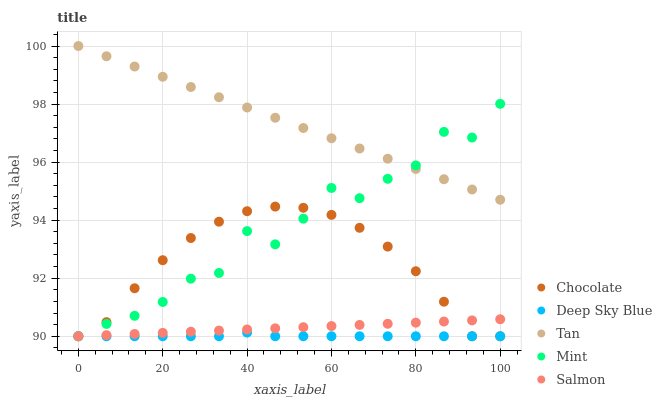Does Deep Sky Blue have the minimum area under the curve?
Answer yes or no. Yes. Does Tan have the maximum area under the curve?
Answer yes or no. Yes. Does Mint have the minimum area under the curve?
Answer yes or no. No. Does Mint have the maximum area under the curve?
Answer yes or no. No. Is Salmon the smoothest?
Answer yes or no. Yes. Is Mint the roughest?
Answer yes or no. Yes. Is Tan the smoothest?
Answer yes or no. No. Is Tan the roughest?
Answer yes or no. No. Does Salmon have the lowest value?
Answer yes or no. Yes. Does Tan have the lowest value?
Answer yes or no. No. Does Tan have the highest value?
Answer yes or no. Yes. Does Mint have the highest value?
Answer yes or no. No. Is Deep Sky Blue less than Tan?
Answer yes or no. Yes. Is Tan greater than Deep Sky Blue?
Answer yes or no. Yes. Does Mint intersect Salmon?
Answer yes or no. Yes. Is Mint less than Salmon?
Answer yes or no. No. Is Mint greater than Salmon?
Answer yes or no. No. Does Deep Sky Blue intersect Tan?
Answer yes or no. No. 